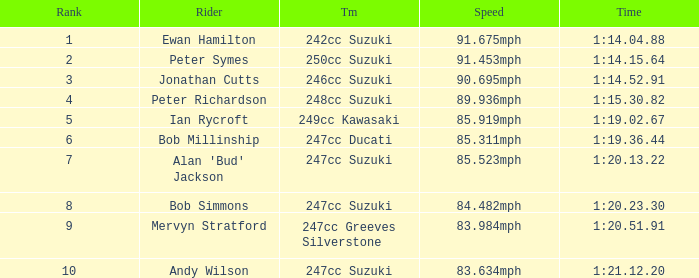Which team had a rank under 4 with a time of 1:14.04.88? 242cc Suzuki. 